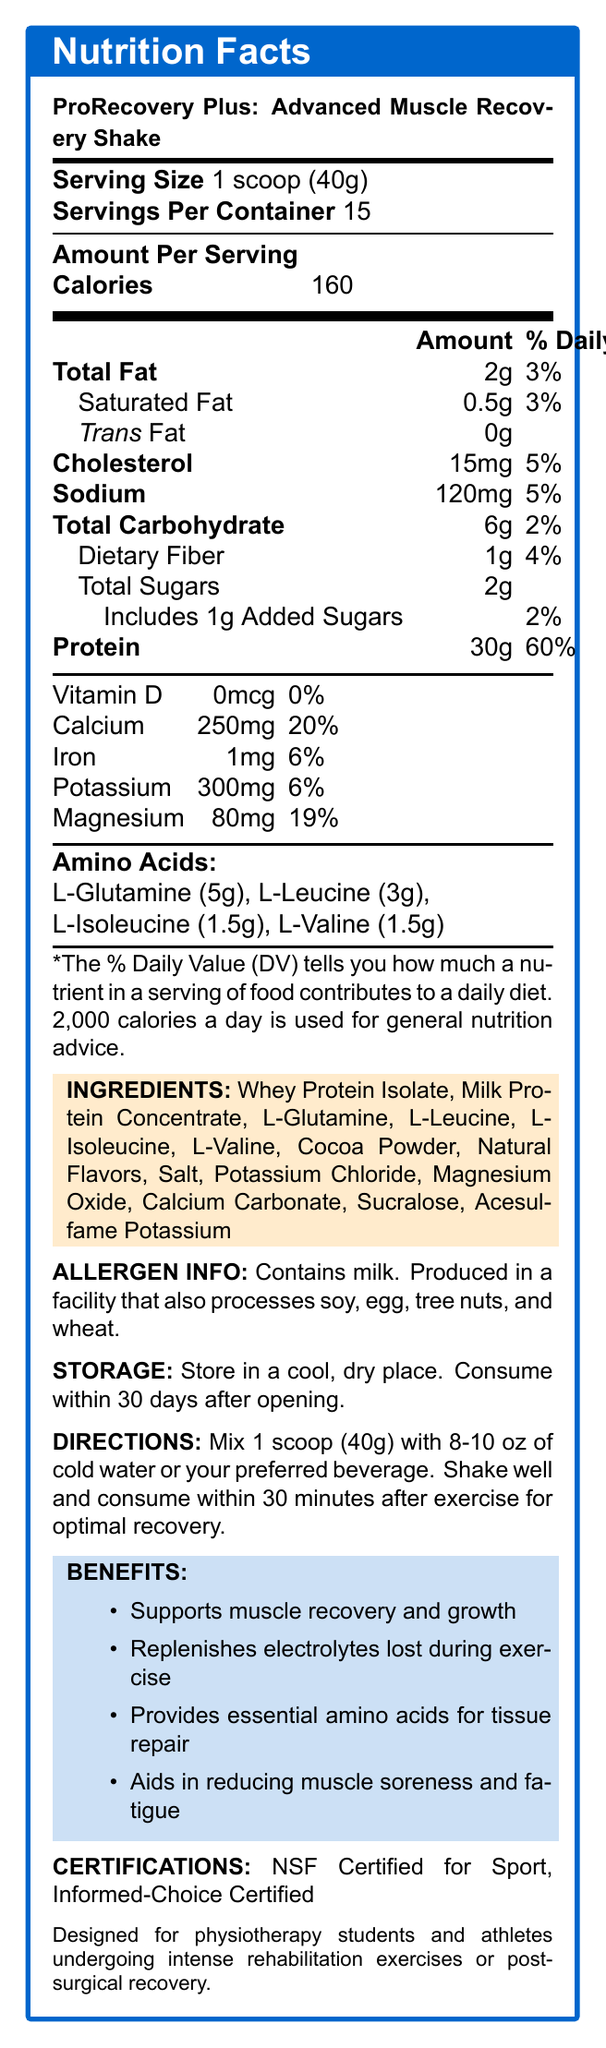what is the serving size for the ProRecovery Plus? The serving size information is clearly listed at the top of the nutrition facts label.
Answer: 1 scoop (40g) how many calories are in one serving of ProRecovery Plus? The calories per serving are mentioned in the 'Amount Per Serving' section on the nutrition facts label.
Answer: 160 how many grams of protein are there in one scoop? The protein content per serving is listed under the 'Amount Per Serving' section.
Answer: 30g what is the percentage daily value of calcium in one serving? The calcium percentage daily value is clearly indicated under the vitamin and minerals section.
Answer: 20% how long should the ProRecovery Plus be consumed after opening? The storage instructions specify consuming the product within 30 days after opening.
Answer: 30 days which of the following amino acids is present in the highest amount? A. L-Leucine B. L-Glutamine C. L-Isoleucine D. L-Valine The amino acid section indicates that L-Glutamine is present in the highest amount with 5g per serving.
Answer: B. L-Glutamine what are the two certifications mentioned for ProRecovery Plus? A. NSF Certified for Sport B. Informed-Choice Certified C. USDA Organic D. Non-GMO Project Verified The certifications are mentioned at the end of the nutrition facts label.
Answer: A. NSF Certified for Sport, B. Informed-Choice Certified is the product suitable for individuals with a soy allergy? The allergen information states that the product is produced in a facility that also processes soy.
Answer: No describe the main benefits of ProRecovery Plus. The benefits are explicitly listed under the 'BENEFITS' section of the label.
Answer: Supports muscle recovery and growth, replenishes electrolytes lost during exercise, provides essential amino acids for tissue repair, aids in reducing muscle soreness and fatigue. who is the target audience for ProRecovery Plus? The target audience is mentioned at the bottom of the document.
Answer: Designed for physiotherapy students and athletes undergoing intense rehabilitation exercises or post-surgical recovery. what are the storage instructions for this product? The storage instructions are listed under the storage section of the label.
Answer: Store in a cool, dry place. how much sodium is in one serving? The sodium content per serving is listed under the 'Amount Per Serving' section.
Answer: 120mg does the product contain any vitamin D? The label indicates that the product contains 0mcg of vitamin D, which is 0% of the daily value.
Answer: No is the product safe for individuals with a tree nuts allergy? The allergen info states that the product is produced in a facility that processes tree nuts, but it does not explicitly confirm safety for individuals with a tree nut allergy.
Answer: Not enough information what is the expiration of the product used in the document, based on the manufacturer details? There is no information provided regarding the expiration date or shelf life of the product in the document.
Answer: Cannot be determined 